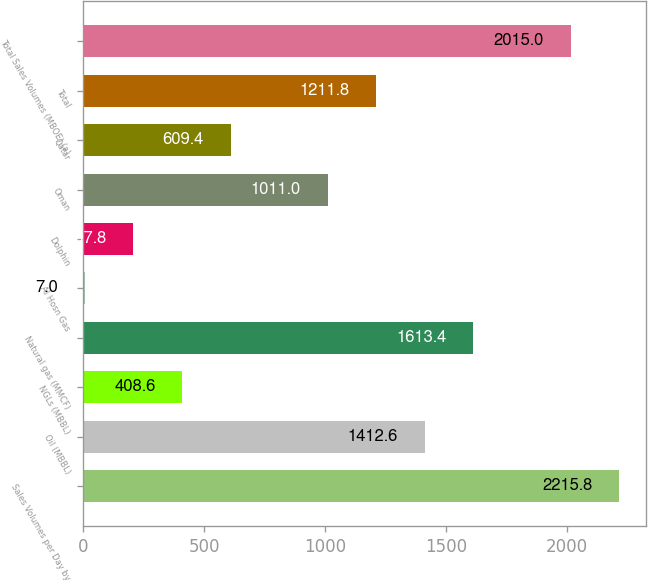Convert chart. <chart><loc_0><loc_0><loc_500><loc_500><bar_chart><fcel>Sales Volumes per Day by<fcel>Oil (MBBL)<fcel>NGLs (MBBL)<fcel>Natural gas (MMCF)<fcel>Al Hosn Gas<fcel>Dolphin<fcel>Oman<fcel>Qatar<fcel>Total<fcel>Total Sales Volumes (MBOE) (a)<nl><fcel>2215.8<fcel>1412.6<fcel>408.6<fcel>1613.4<fcel>7<fcel>207.8<fcel>1011<fcel>609.4<fcel>1211.8<fcel>2015<nl></chart> 